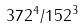<formula> <loc_0><loc_0><loc_500><loc_500>3 7 2 ^ { 4 } / 1 5 2 ^ { 3 }</formula> 